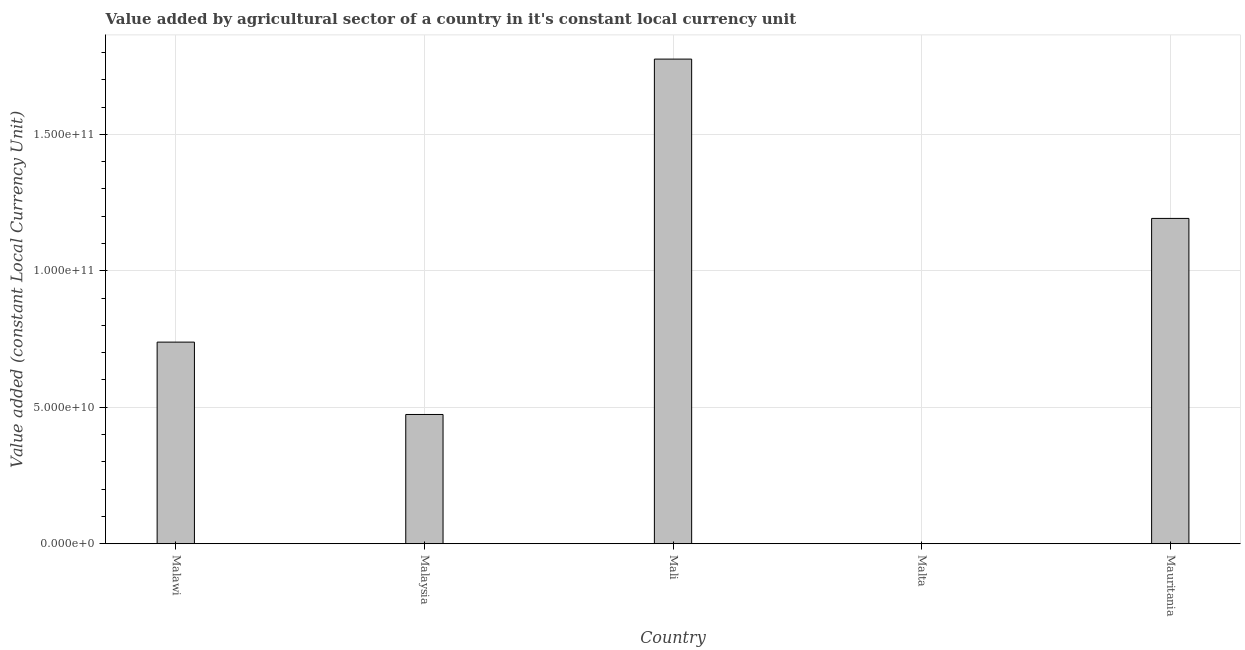Does the graph contain any zero values?
Give a very brief answer. No. What is the title of the graph?
Your response must be concise. Value added by agricultural sector of a country in it's constant local currency unit. What is the label or title of the X-axis?
Offer a very short reply. Country. What is the label or title of the Y-axis?
Provide a succinct answer. Value added (constant Local Currency Unit). What is the value added by agriculture sector in Malaysia?
Your answer should be compact. 4.74e+1. Across all countries, what is the maximum value added by agriculture sector?
Make the answer very short. 1.78e+11. Across all countries, what is the minimum value added by agriculture sector?
Ensure brevity in your answer.  8.57e+07. In which country was the value added by agriculture sector maximum?
Make the answer very short. Mali. In which country was the value added by agriculture sector minimum?
Provide a succinct answer. Malta. What is the sum of the value added by agriculture sector?
Your answer should be very brief. 4.18e+11. What is the difference between the value added by agriculture sector in Malta and Mauritania?
Ensure brevity in your answer.  -1.19e+11. What is the average value added by agriculture sector per country?
Ensure brevity in your answer.  8.36e+1. What is the median value added by agriculture sector?
Provide a succinct answer. 7.39e+1. What is the ratio of the value added by agriculture sector in Malaysia to that in Malta?
Provide a succinct answer. 552.81. Is the value added by agriculture sector in Malawi less than that in Mali?
Offer a terse response. Yes. What is the difference between the highest and the second highest value added by agriculture sector?
Your answer should be compact. 5.84e+1. What is the difference between the highest and the lowest value added by agriculture sector?
Ensure brevity in your answer.  1.77e+11. In how many countries, is the value added by agriculture sector greater than the average value added by agriculture sector taken over all countries?
Make the answer very short. 2. How many bars are there?
Your answer should be very brief. 5. How many countries are there in the graph?
Ensure brevity in your answer.  5. What is the difference between two consecutive major ticks on the Y-axis?
Your answer should be compact. 5.00e+1. What is the Value added (constant Local Currency Unit) of Malawi?
Keep it short and to the point. 7.39e+1. What is the Value added (constant Local Currency Unit) in Malaysia?
Your answer should be compact. 4.74e+1. What is the Value added (constant Local Currency Unit) of Mali?
Your response must be concise. 1.78e+11. What is the Value added (constant Local Currency Unit) in Malta?
Make the answer very short. 8.57e+07. What is the Value added (constant Local Currency Unit) of Mauritania?
Provide a succinct answer. 1.19e+11. What is the difference between the Value added (constant Local Currency Unit) in Malawi and Malaysia?
Offer a terse response. 2.65e+1. What is the difference between the Value added (constant Local Currency Unit) in Malawi and Mali?
Your answer should be very brief. -1.04e+11. What is the difference between the Value added (constant Local Currency Unit) in Malawi and Malta?
Give a very brief answer. 7.38e+1. What is the difference between the Value added (constant Local Currency Unit) in Malawi and Mauritania?
Your answer should be compact. -4.53e+1. What is the difference between the Value added (constant Local Currency Unit) in Malaysia and Mali?
Your response must be concise. -1.30e+11. What is the difference between the Value added (constant Local Currency Unit) in Malaysia and Malta?
Give a very brief answer. 4.73e+1. What is the difference between the Value added (constant Local Currency Unit) in Malaysia and Mauritania?
Provide a succinct answer. -7.18e+1. What is the difference between the Value added (constant Local Currency Unit) in Mali and Malta?
Ensure brevity in your answer.  1.77e+11. What is the difference between the Value added (constant Local Currency Unit) in Mali and Mauritania?
Provide a short and direct response. 5.84e+1. What is the difference between the Value added (constant Local Currency Unit) in Malta and Mauritania?
Your response must be concise. -1.19e+11. What is the ratio of the Value added (constant Local Currency Unit) in Malawi to that in Malaysia?
Your answer should be very brief. 1.56. What is the ratio of the Value added (constant Local Currency Unit) in Malawi to that in Mali?
Provide a short and direct response. 0.42. What is the ratio of the Value added (constant Local Currency Unit) in Malawi to that in Malta?
Ensure brevity in your answer.  862.23. What is the ratio of the Value added (constant Local Currency Unit) in Malawi to that in Mauritania?
Offer a terse response. 0.62. What is the ratio of the Value added (constant Local Currency Unit) in Malaysia to that in Mali?
Offer a terse response. 0.27. What is the ratio of the Value added (constant Local Currency Unit) in Malaysia to that in Malta?
Keep it short and to the point. 552.81. What is the ratio of the Value added (constant Local Currency Unit) in Malaysia to that in Mauritania?
Provide a succinct answer. 0.4. What is the ratio of the Value added (constant Local Currency Unit) in Mali to that in Malta?
Your answer should be very brief. 2072.44. What is the ratio of the Value added (constant Local Currency Unit) in Mali to that in Mauritania?
Ensure brevity in your answer.  1.49. 